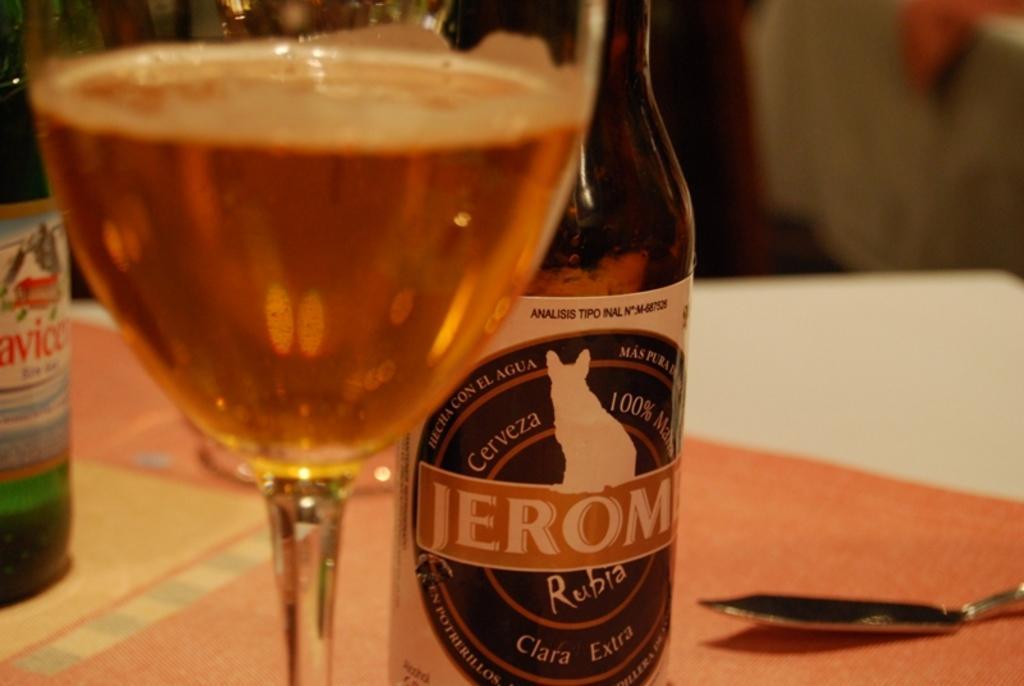Describe this image in one or two sentences. In this image i can see a glass with wine in it, a glass bottle with a sticker attached to it and a spoon on the table. In the background i can see another glass bottle on the table. 